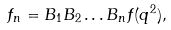<formula> <loc_0><loc_0><loc_500><loc_500>f _ { n } = B _ { 1 } B _ { 2 } \dots B _ { n } f ( q ^ { 2 } ) ,</formula> 